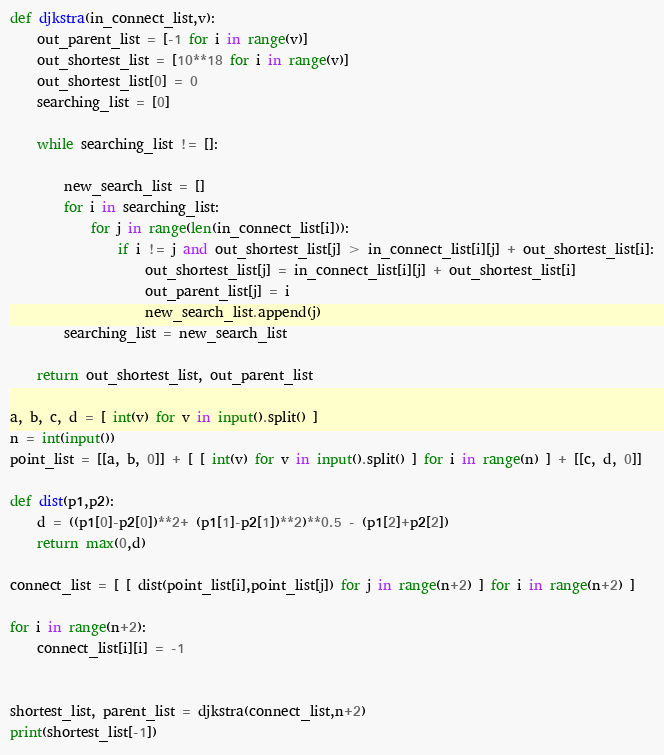Convert code to text. <code><loc_0><loc_0><loc_500><loc_500><_Python_>def djkstra(in_connect_list,v):
    out_parent_list = [-1 for i in range(v)]
    out_shortest_list = [10**18 for i in range(v)]
    out_shortest_list[0] = 0
    searching_list = [0]
    
    while searching_list != []:
    
        new_search_list = []
        for i in searching_list:
            for j in range(len(in_connect_list[i])):
                if i != j and out_shortest_list[j] > in_connect_list[i][j] + out_shortest_list[i]:
                    out_shortest_list[j] = in_connect_list[i][j] + out_shortest_list[i]
                    out_parent_list[j] = i
                    new_search_list.append(j)
        searching_list = new_search_list

    return out_shortest_list, out_parent_list

a, b, c, d = [ int(v) for v in input().split() ]
n = int(input())
point_list = [[a, b, 0]] + [ [ int(v) for v in input().split() ] for i in range(n) ] + [[c, d, 0]]

def dist(p1,p2):
    d = ((p1[0]-p2[0])**2+ (p1[1]-p2[1])**2)**0.5 - (p1[2]+p2[2])
    return max(0,d)

connect_list = [ [ dist(point_list[i],point_list[j]) for j in range(n+2) ] for i in range(n+2) ]

for i in range(n+2):
    connect_list[i][i] = -1


shortest_list, parent_list = djkstra(connect_list,n+2)
print(shortest_list[-1])</code> 